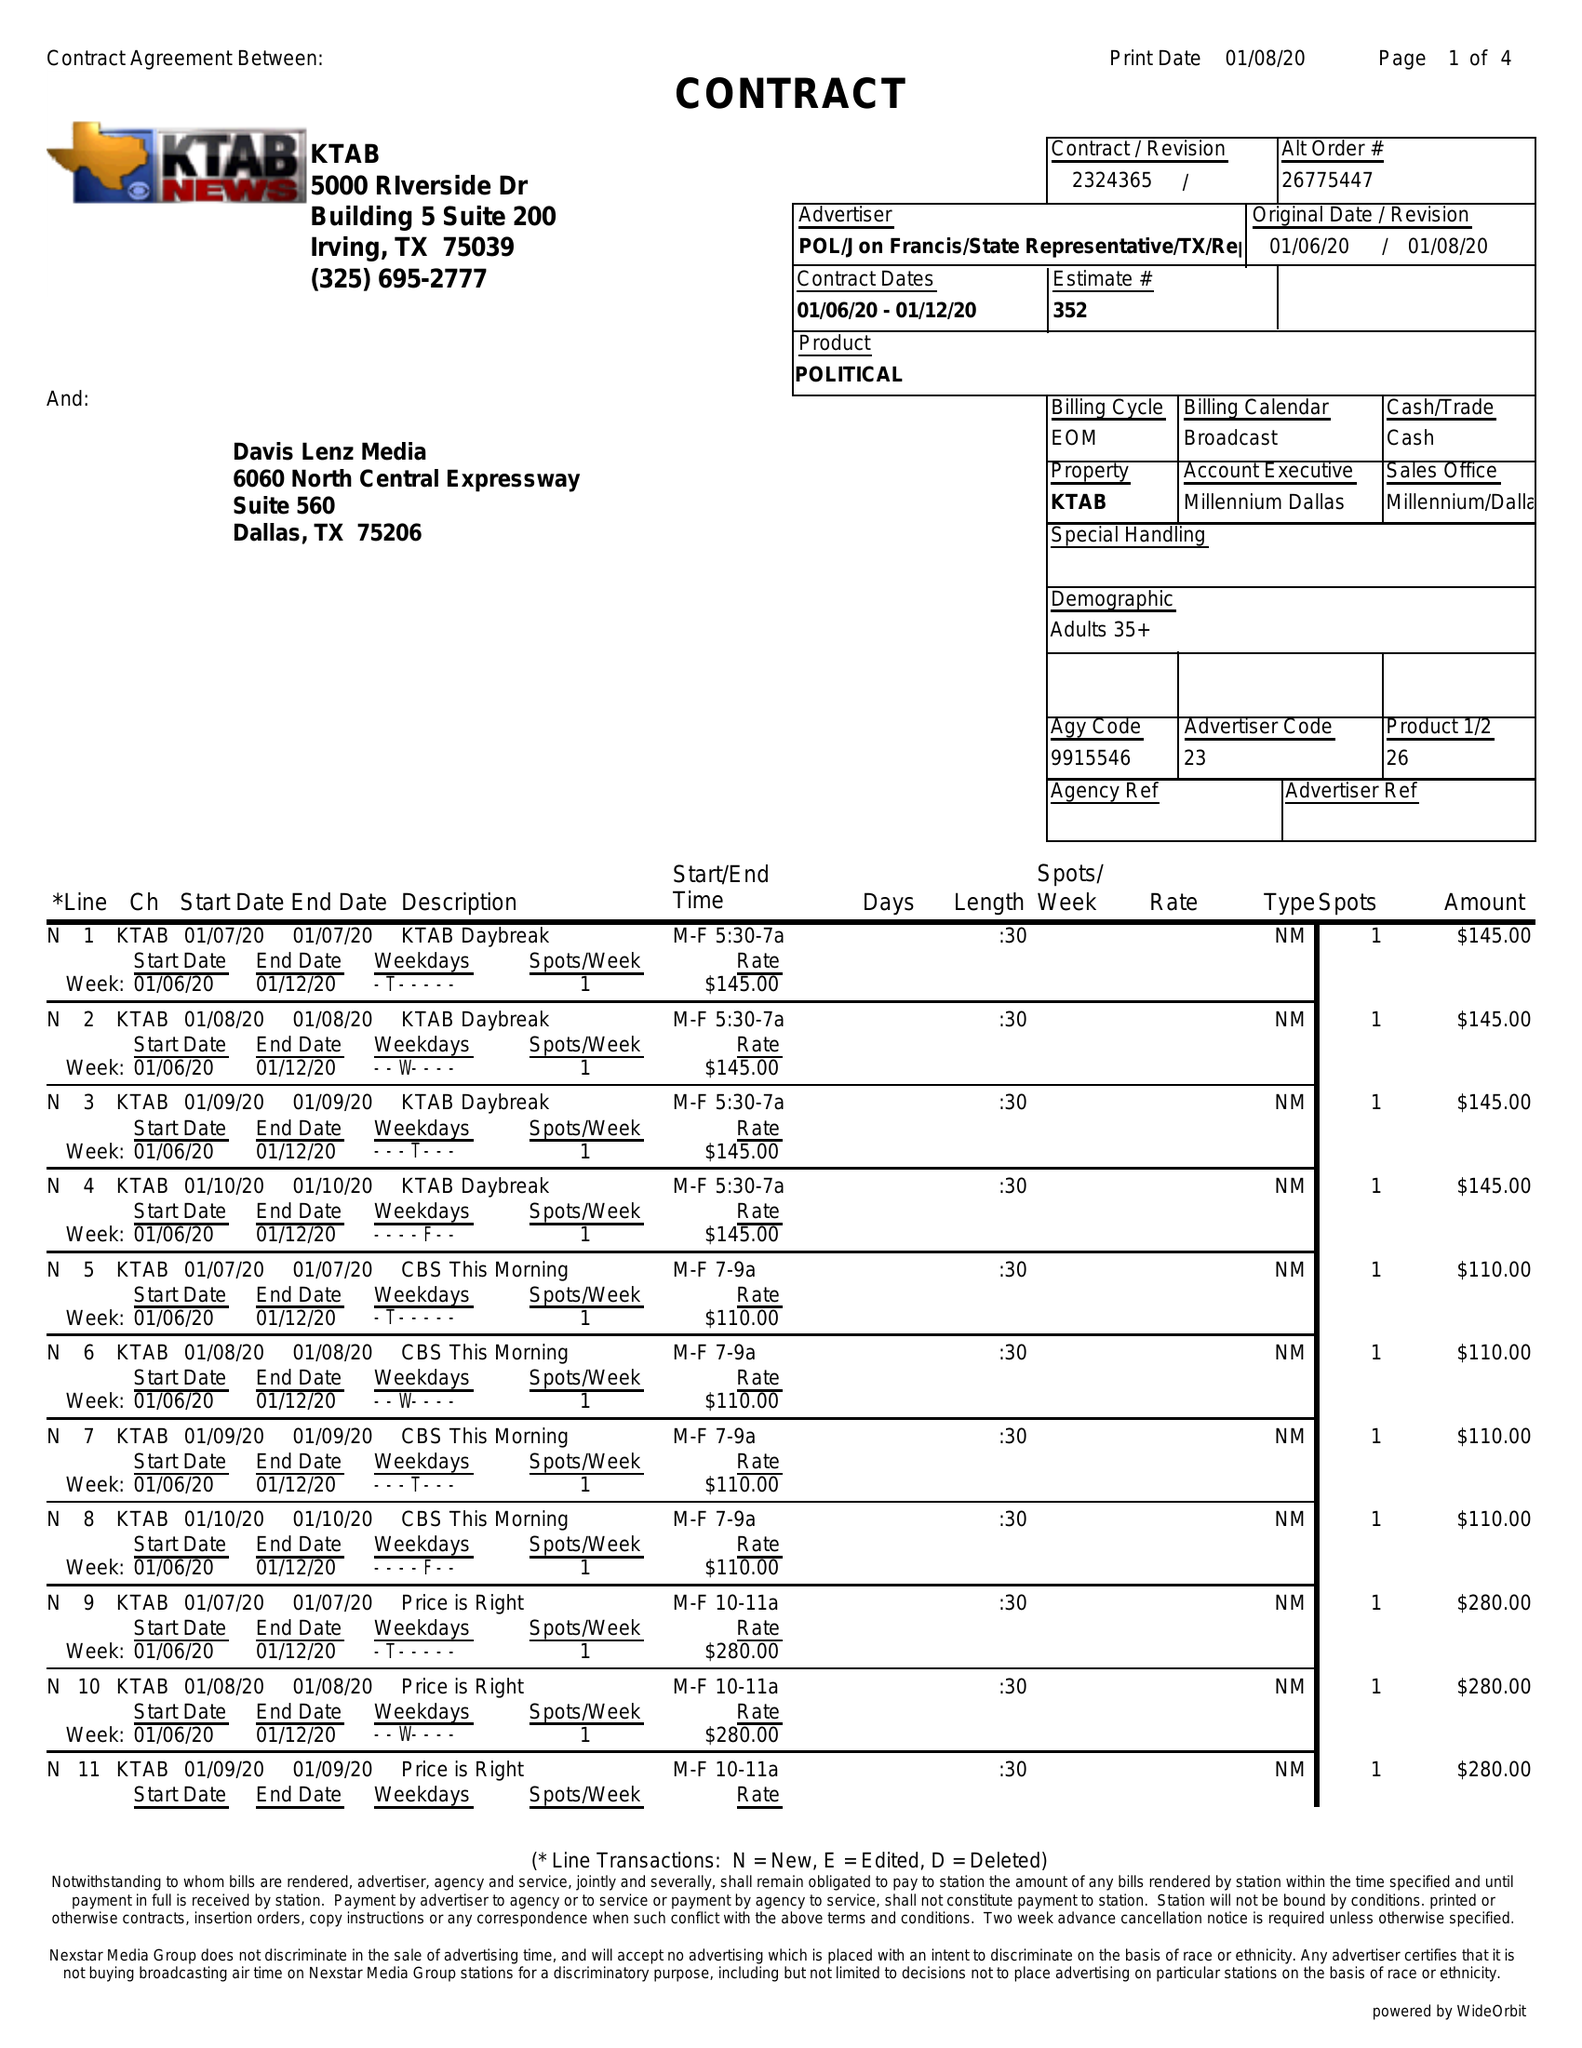What is the value for the contract_num?
Answer the question using a single word or phrase. 2324365 